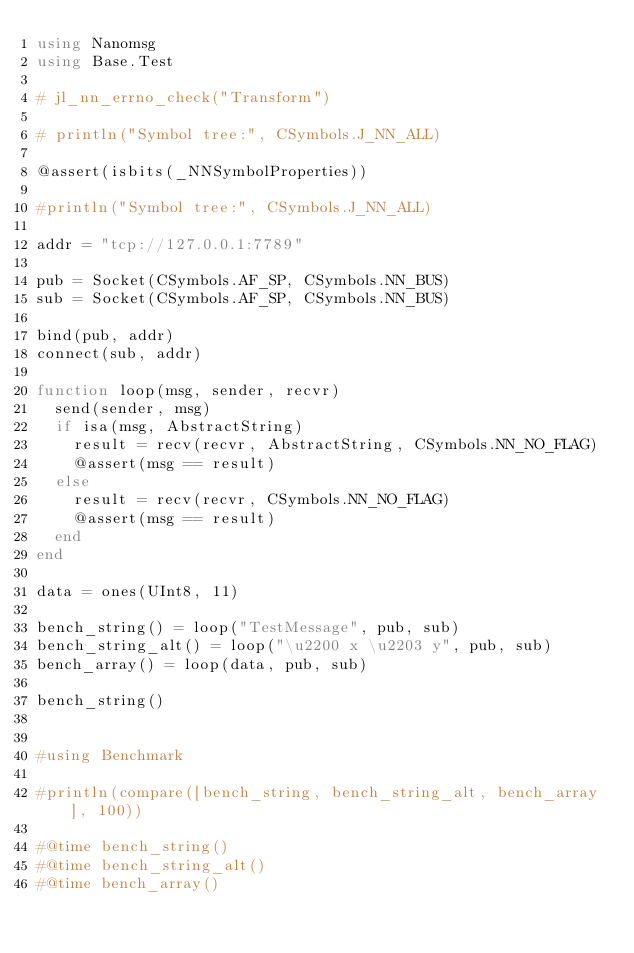Convert code to text. <code><loc_0><loc_0><loc_500><loc_500><_Julia_>using Nanomsg
using Base.Test

# jl_nn_errno_check("Transform")

# println("Symbol tree:", CSymbols.J_NN_ALL)

@assert(isbits(_NNSymbolProperties))

#println("Symbol tree:", CSymbols.J_NN_ALL)

addr = "tcp://127.0.0.1:7789"

pub = Socket(CSymbols.AF_SP, CSymbols.NN_BUS)
sub = Socket(CSymbols.AF_SP, CSymbols.NN_BUS)

bind(pub, addr)
connect(sub, addr)

function loop(msg, sender, recvr)
	send(sender, msg)
	if isa(msg, AbstractString)
		result = recv(recvr, AbstractString, CSymbols.NN_NO_FLAG)
		@assert(msg == result)
	else
		result = recv(recvr, CSymbols.NN_NO_FLAG)
		@assert(msg == result)
	end
end

data = ones(UInt8, 11)

bench_string() = loop("TestMessage", pub, sub)
bench_string_alt() = loop("\u2200 x \u2203 y", pub, sub)
bench_array() = loop(data, pub, sub)

bench_string()


#using Benchmark

#println(compare([bench_string, bench_string_alt, bench_array], 100))

#@time bench_string()
#@time bench_string_alt()
#@time bench_array()</code> 